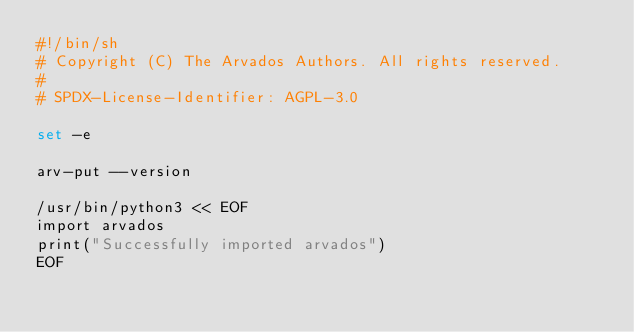Convert code to text. <code><loc_0><loc_0><loc_500><loc_500><_Bash_>#!/bin/sh
# Copyright (C) The Arvados Authors. All rights reserved.
#
# SPDX-License-Identifier: AGPL-3.0

set -e

arv-put --version

/usr/bin/python3 << EOF
import arvados
print("Successfully imported arvados")
EOF
</code> 